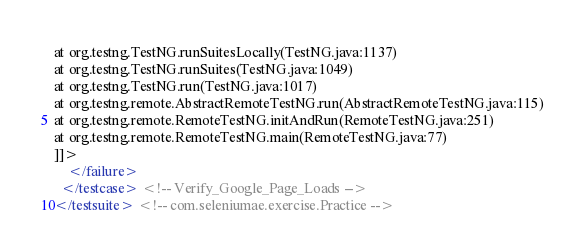<code> <loc_0><loc_0><loc_500><loc_500><_XML_>at org.testng.TestNG.runSuitesLocally(TestNG.java:1137)
at org.testng.TestNG.runSuites(TestNG.java:1049)
at org.testng.TestNG.run(TestNG.java:1017)
at org.testng.remote.AbstractRemoteTestNG.run(AbstractRemoteTestNG.java:115)
at org.testng.remote.RemoteTestNG.initAndRun(RemoteTestNG.java:251)
at org.testng.remote.RemoteTestNG.main(RemoteTestNG.java:77)
]]>
    </failure>
  </testcase> <!-- Verify_Google_Page_Loads -->
</testsuite> <!-- com.seleniumae.exercise.Practice -->
</code> 